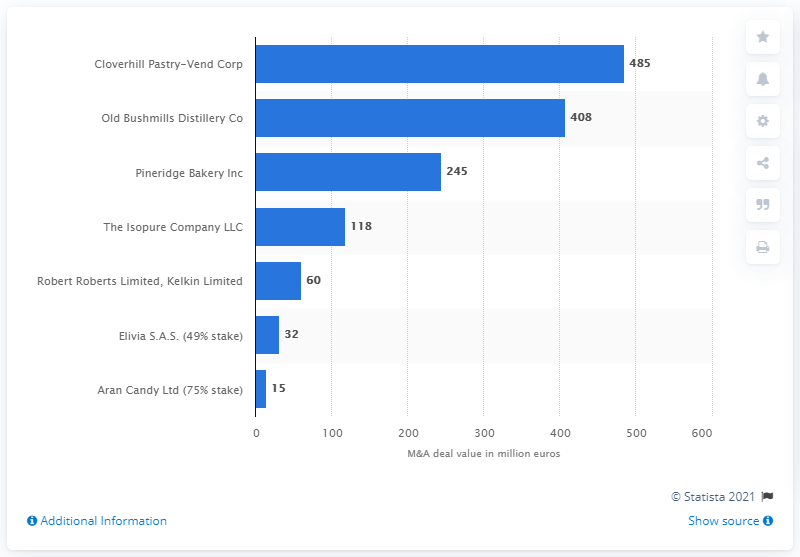Mention a couple of crucial points in this snapshot. Grupo Cuervo SA de CV paid 408 for the Old Bushmills Distillery Co. 